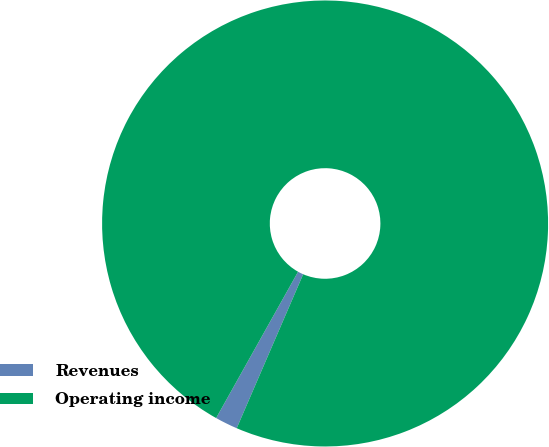Convert chart to OTSL. <chart><loc_0><loc_0><loc_500><loc_500><pie_chart><fcel>Revenues<fcel>Operating income<nl><fcel>1.64%<fcel>98.36%<nl></chart> 